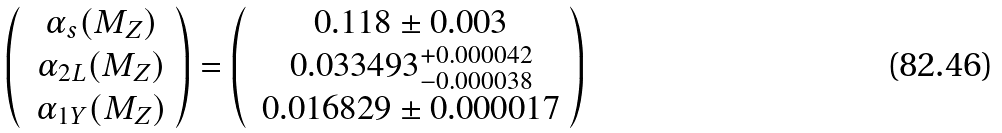<formula> <loc_0><loc_0><loc_500><loc_500>\left ( \begin{array} { c c } \ \alpha _ { s } ( M _ { Z } ) \\ \ \alpha _ { 2 L } ( M _ { Z } ) \\ \ \alpha _ { 1 Y } ( M _ { Z } ) \end{array} \right ) = \left ( \begin{array} { c c } \ 0 . 1 1 8 \pm 0 . 0 0 3 \\ \ 0 . 0 3 3 4 9 3 ^ { + 0 . 0 0 0 0 4 2 } _ { - 0 . 0 0 0 0 3 8 } \\ \ 0 . 0 1 6 8 2 9 \pm 0 . 0 0 0 0 1 7 \end{array} \right )</formula> 